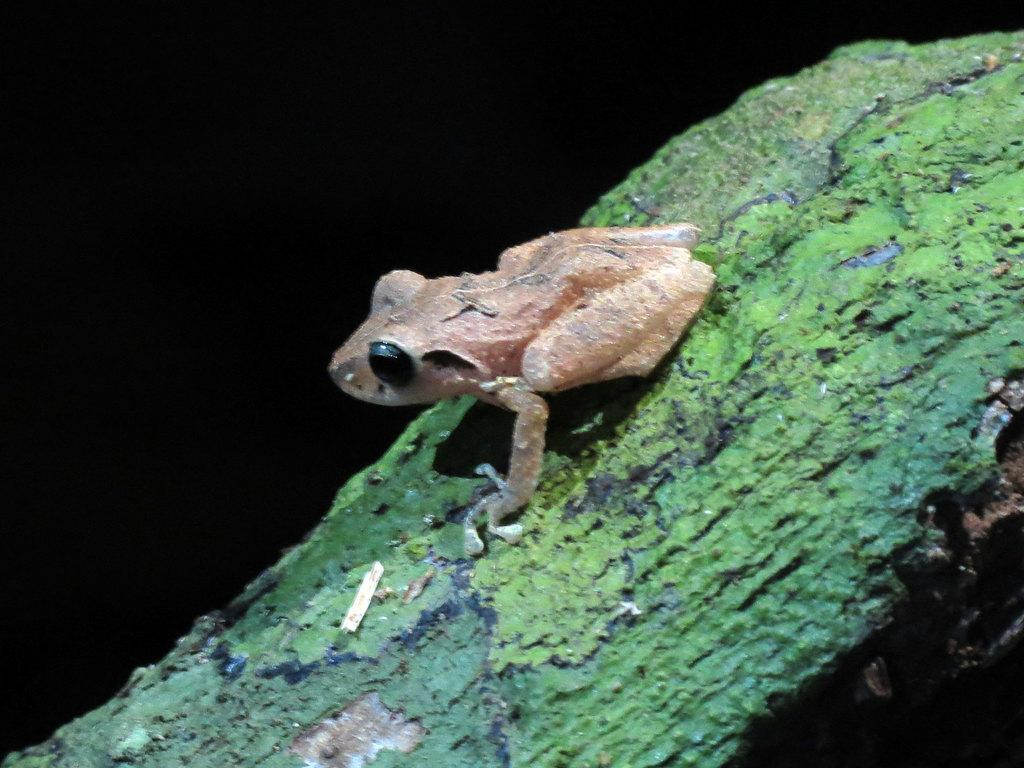What animal is present in the image? There is a frog in the image. Where is the frog located? The frog is on tree bark. What can be observed about the background of the image? The background of the image is dark. How many legs can be seen on the flowers in the image? There are no flowers present in the image, so it is not possible to determine the number of legs on any flowers. 